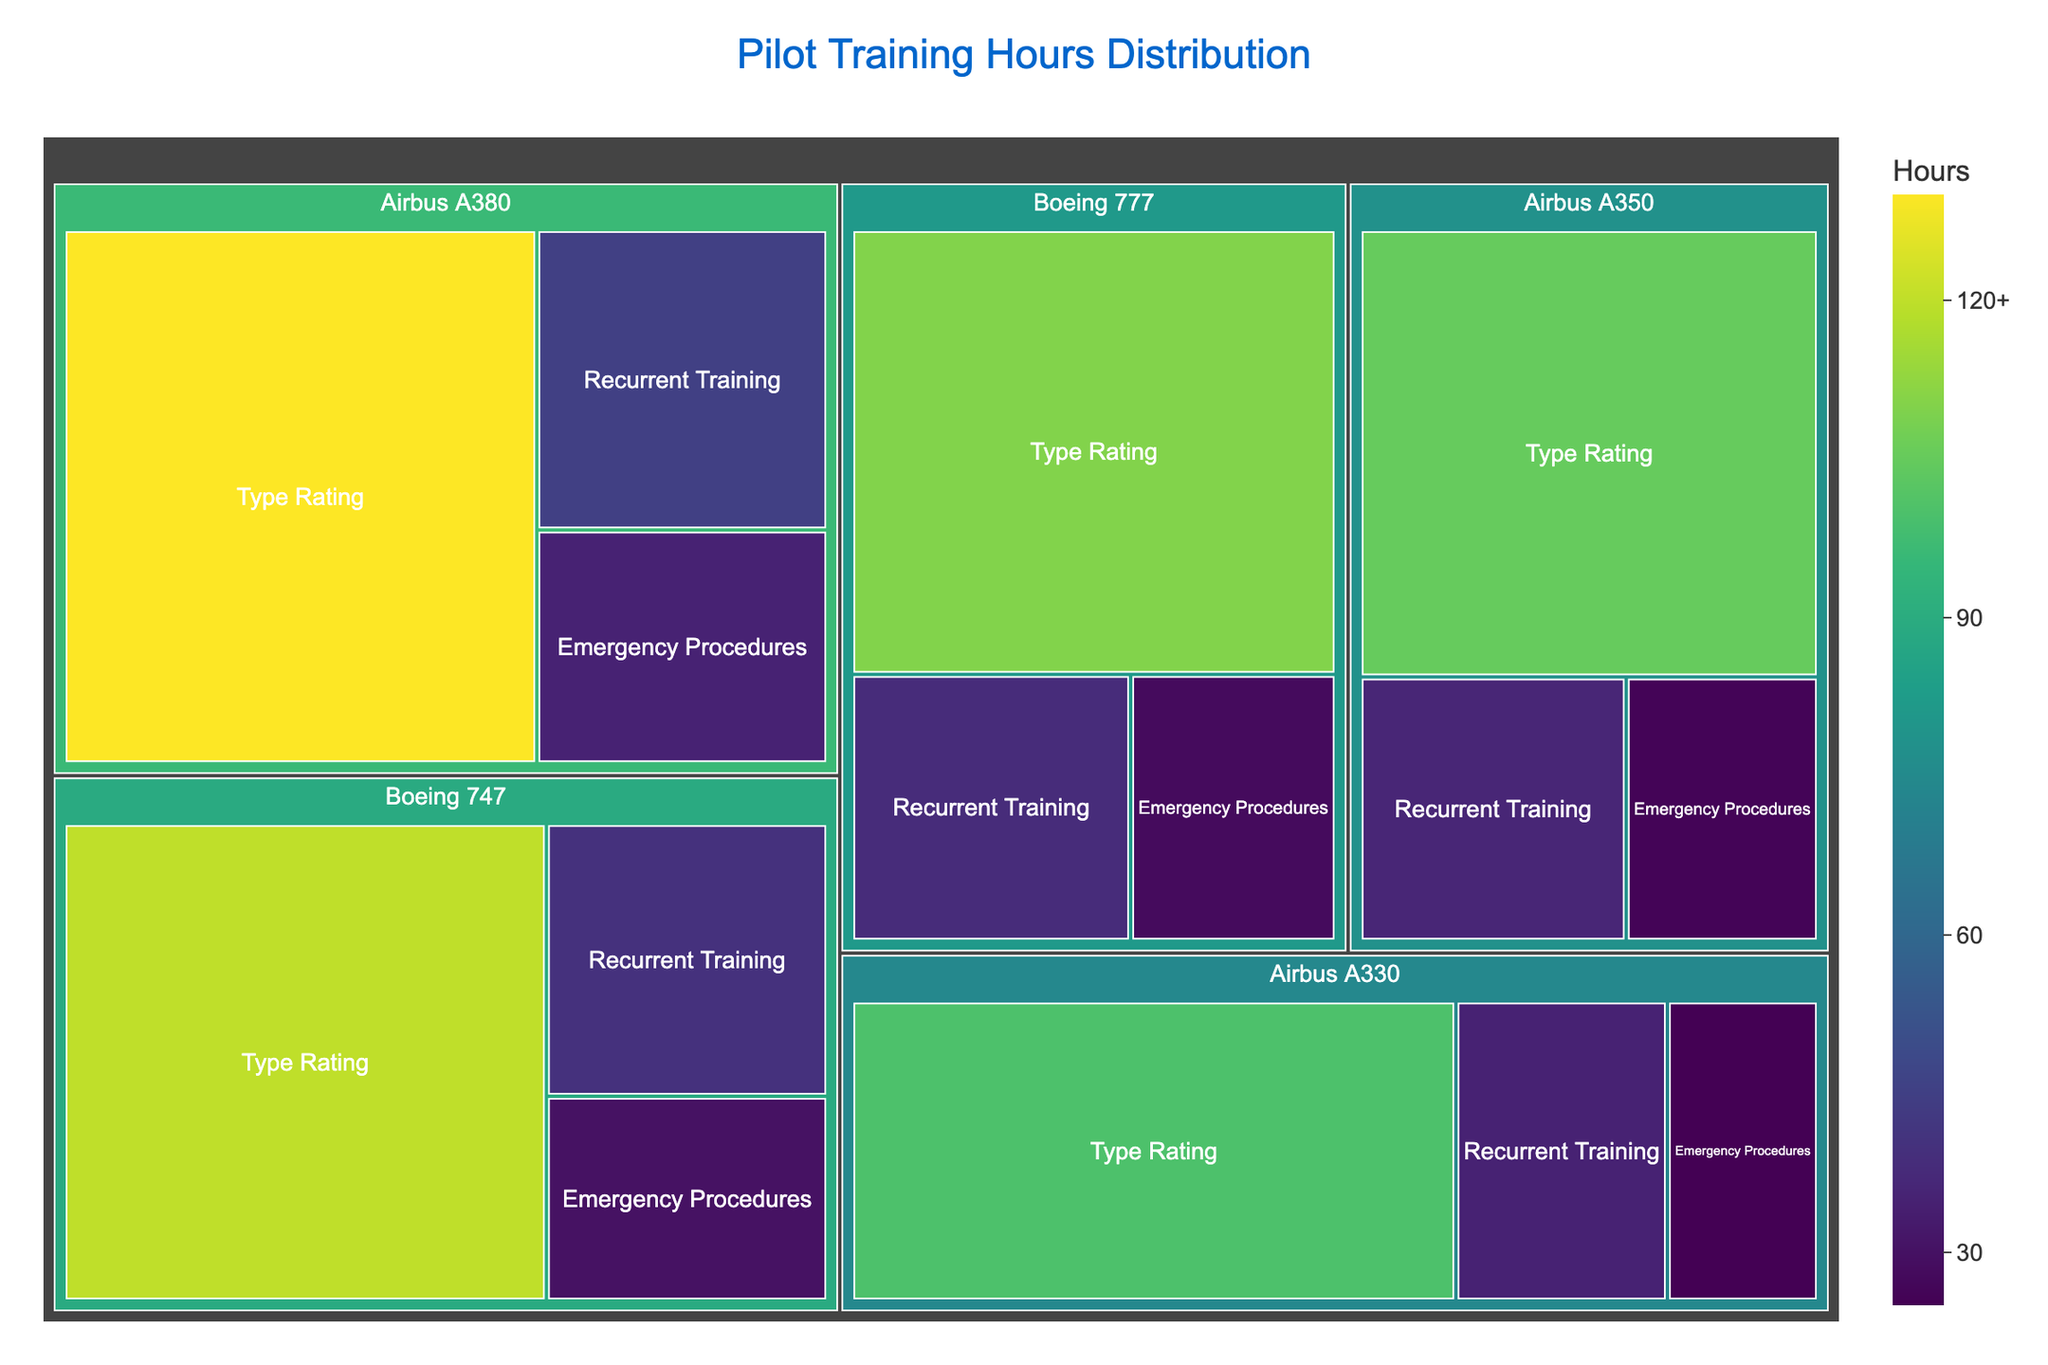What is the title of the treemap? The title is typically shown at the top of the figure, and it summarizes what the treemap represents. In this case, the title is "Pilot Training Hours Distribution".
Answer: Pilot Training Hours Distribution Which aircraft type has the highest training hours for Type Rating certification? Find the segment corresponding to Type Rating under each aircraft type and compare their values. The highest value is 130 hours for Airbus A380.
Answer: Airbus A380 How many total training hours are allocated for Boeing 747? Sum the training hours for all certifications under Boeing 747: 120 (Type Rating) + 40 (Recurrent Training) + 30 (Emergency Procedures) = 190 hours.
Answer: 190 Between Airbus A330 and Boeing 777, which aircraft type requires more total training hours? Sum the training hours for all certifications for each aircraft type: Airbus A330 (100 + 35 + 25 = 160) and Boeing 777 (110 + 38 + 28 = 176). Boeing 777 requires more training hours.
Answer: Boeing 777 What is the average training hours for Recurrent Training across all aircraft types? Sum the training hours for Recurrent Training across all aircraft types: 40 (Boeing 747) + 35 (Airbus A330) + 38 (Boeing 777) + 45 (Airbus A380) + 36 (Airbus A350) = 194. Divide by the number of aircraft types (5): 194 / 5 = 38.8 hours.
Answer: 38.8 Which certification requires the least training hours for the Airbus A350? Look at the values for all the certifications under Airbus A350: Type Rating (105), Recurrent Training (36), Emergency Procedures (26). The least is for Emergency Procedures, which is 26 hours.
Answer: Emergency Procedures Rank the aircraft types in descending order of their total training hours. Calculate the total training hours for each aircraft type: Boeing 747 (190), Airbus A330 (160), Boeing 777 (176), Airbus A380 (210), Airbus A350 (167). In descending order: Airbus A380 (210), Boeing 747 (190), Boeing 777 (176), Airbus A350 (167), Airbus A330 (160).
Answer: Airbus A380, Boeing 747, Boeing 777, Airbus A350, Airbus A330 How does the training hours distribution for Type Rating certification compare between Boeing and Airbus? Sum the Type Rating training hours for Boeing aircraft types: Boeing 747 (120), Boeing 777 (110) = 230. Sum the Type Rating training hours for Airbus aircraft types: Airbus A330 (100), Airbus A380 (130), Airbus A350 (105) = 335. Airbus has more hours.
Answer: Airbus has more hours What percentage of total training hours for Airbus A380 is allocated to Emergency Procedures? Calculate the total hours for Airbus A380: 130 (Type Rating) + 45 (Recurrent Training) + 35 (Emergency Procedures) = 210. Emergency Procedures is 35 hours. The percentage is (35 / 210) * 100 = 16.67%.
Answer: 16.67% Which certification generally requires the most training hours across all aircraft types? Compare the total training hours for each certification by summing across all aircraft types: Type Rating (665), Recurrent Training (194), Emergency Procedures (144). Type Rating requires the most hours.
Answer: Type Rating 